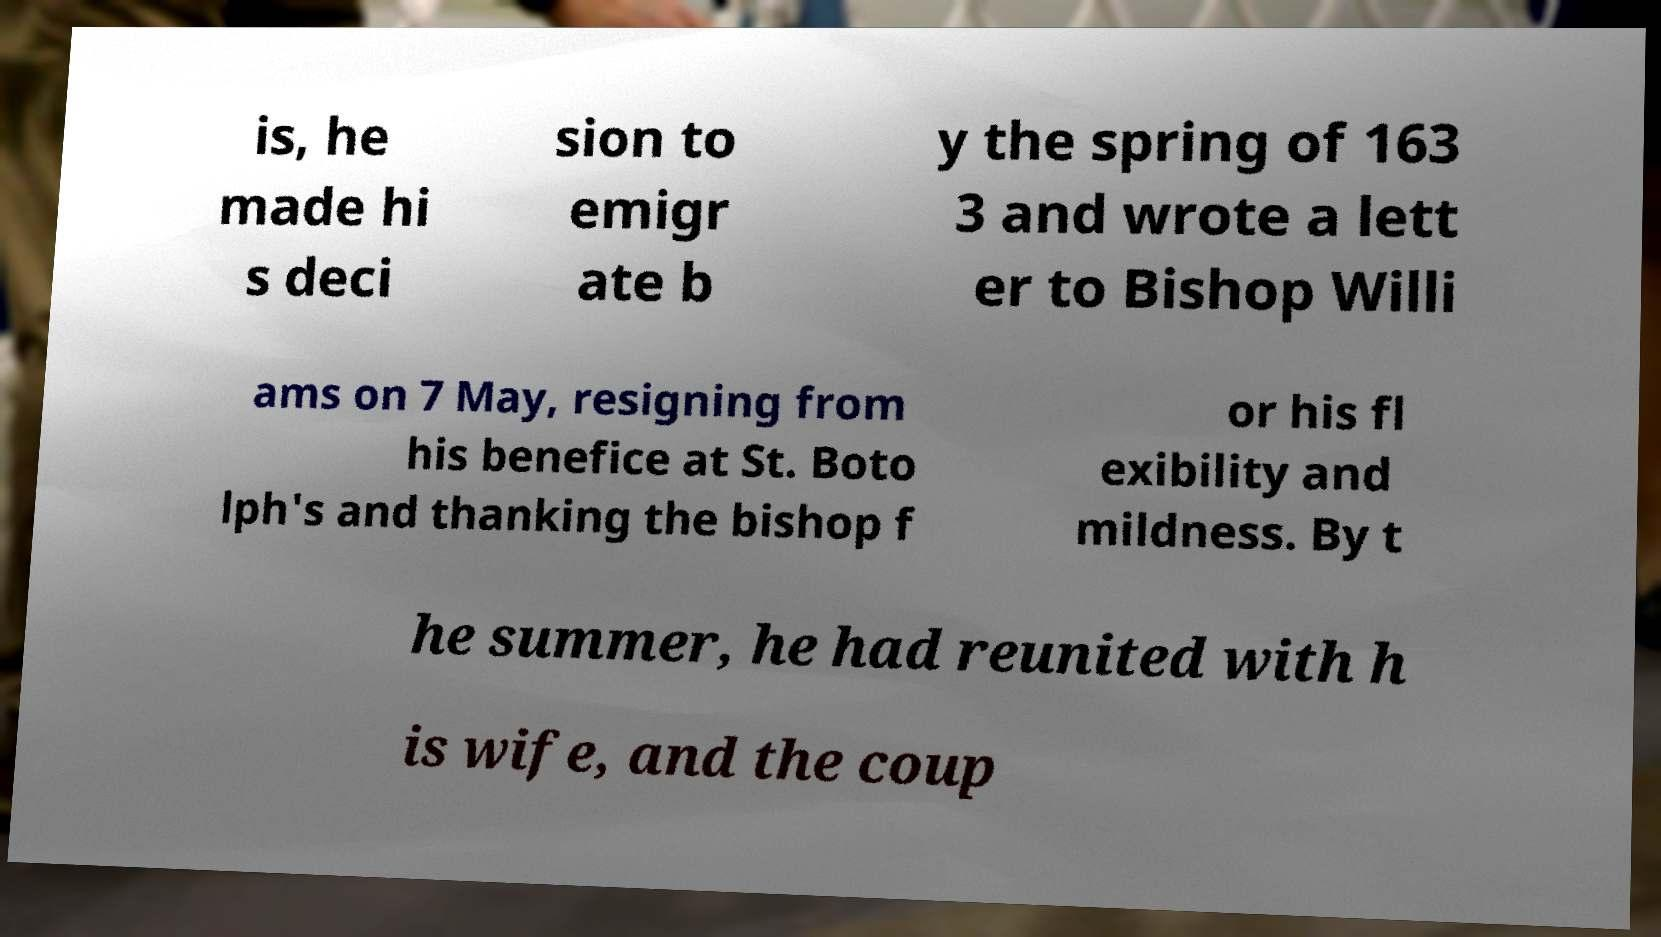Could you assist in decoding the text presented in this image and type it out clearly? is, he made hi s deci sion to emigr ate b y the spring of 163 3 and wrote a lett er to Bishop Willi ams on 7 May, resigning from his benefice at St. Boto lph's and thanking the bishop f or his fl exibility and mildness. By t he summer, he had reunited with h is wife, and the coup 